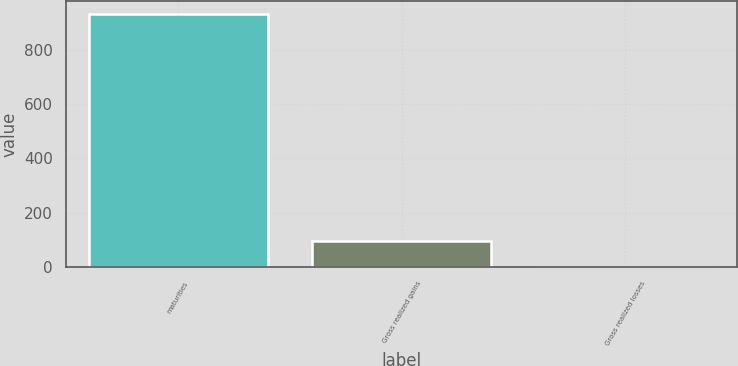Convert chart. <chart><loc_0><loc_0><loc_500><loc_500><bar_chart><fcel>maturities<fcel>Gross realized gains<fcel>Gross realized losses<nl><fcel>931<fcel>94.9<fcel>2<nl></chart> 